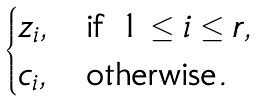<formula> <loc_0><loc_0><loc_500><loc_500>\begin{cases} z _ { i } , & \text {if $1 \leq i \leq r$} , \\ c _ { i } , & \text {otherwise} . \end{cases}</formula> 